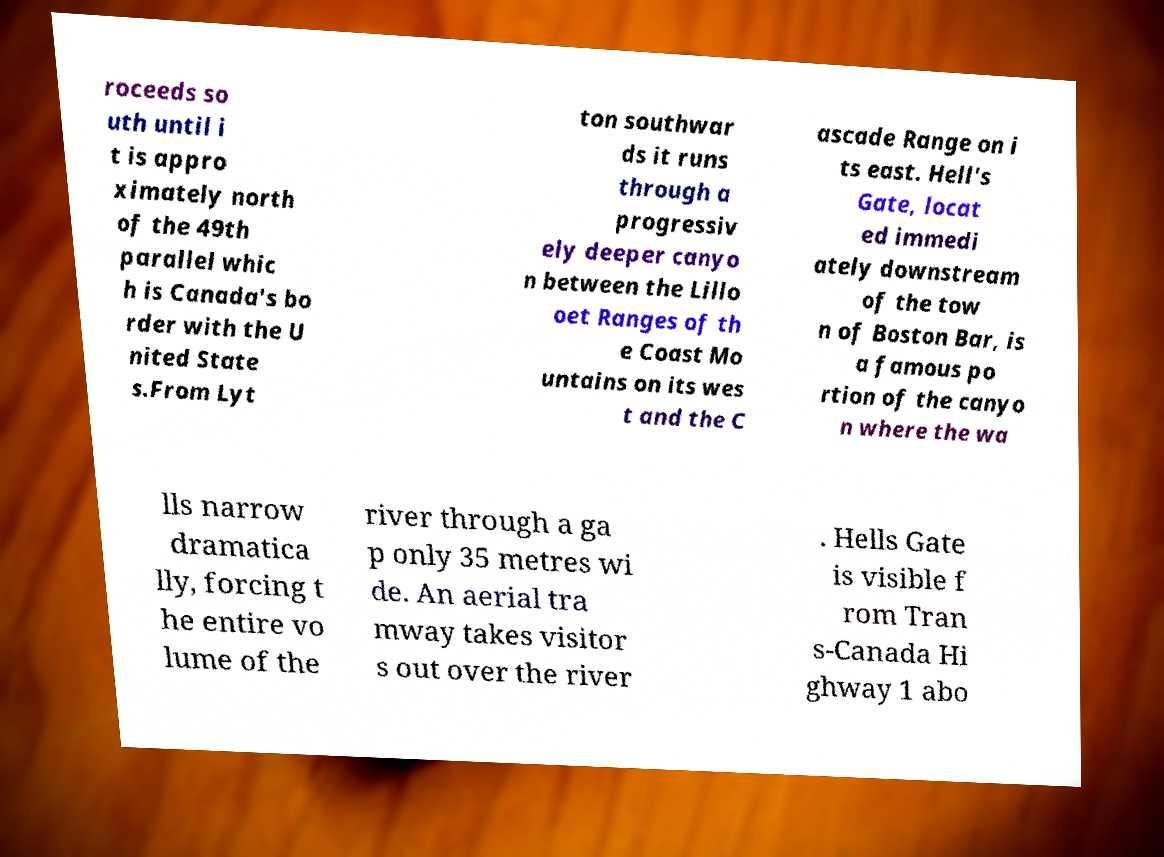I need the written content from this picture converted into text. Can you do that? roceeds so uth until i t is appro ximately north of the 49th parallel whic h is Canada's bo rder with the U nited State s.From Lyt ton southwar ds it runs through a progressiv ely deeper canyo n between the Lillo oet Ranges of th e Coast Mo untains on its wes t and the C ascade Range on i ts east. Hell's Gate, locat ed immedi ately downstream of the tow n of Boston Bar, is a famous po rtion of the canyo n where the wa lls narrow dramatica lly, forcing t he entire vo lume of the river through a ga p only 35 metres wi de. An aerial tra mway takes visitor s out over the river . Hells Gate is visible f rom Tran s-Canada Hi ghway 1 abo 